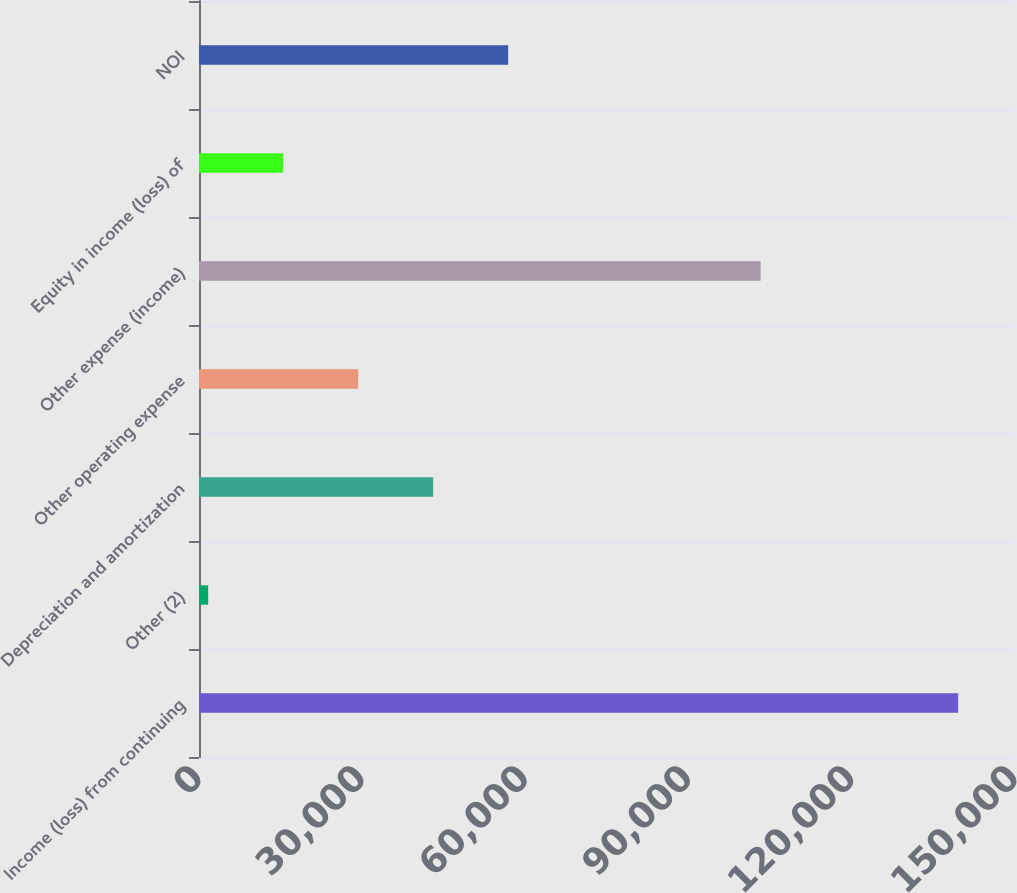Convert chart to OTSL. <chart><loc_0><loc_0><loc_500><loc_500><bar_chart><fcel>Income (loss) from continuing<fcel>Other (2)<fcel>Depreciation and amortization<fcel>Other operating expense<fcel>Other expense (income)<fcel>Equity in income (loss) of<fcel>NOI<nl><fcel>139549<fcel>1685<fcel>43044.2<fcel>29257.8<fcel>103241<fcel>15471.4<fcel>56830.6<nl></chart> 